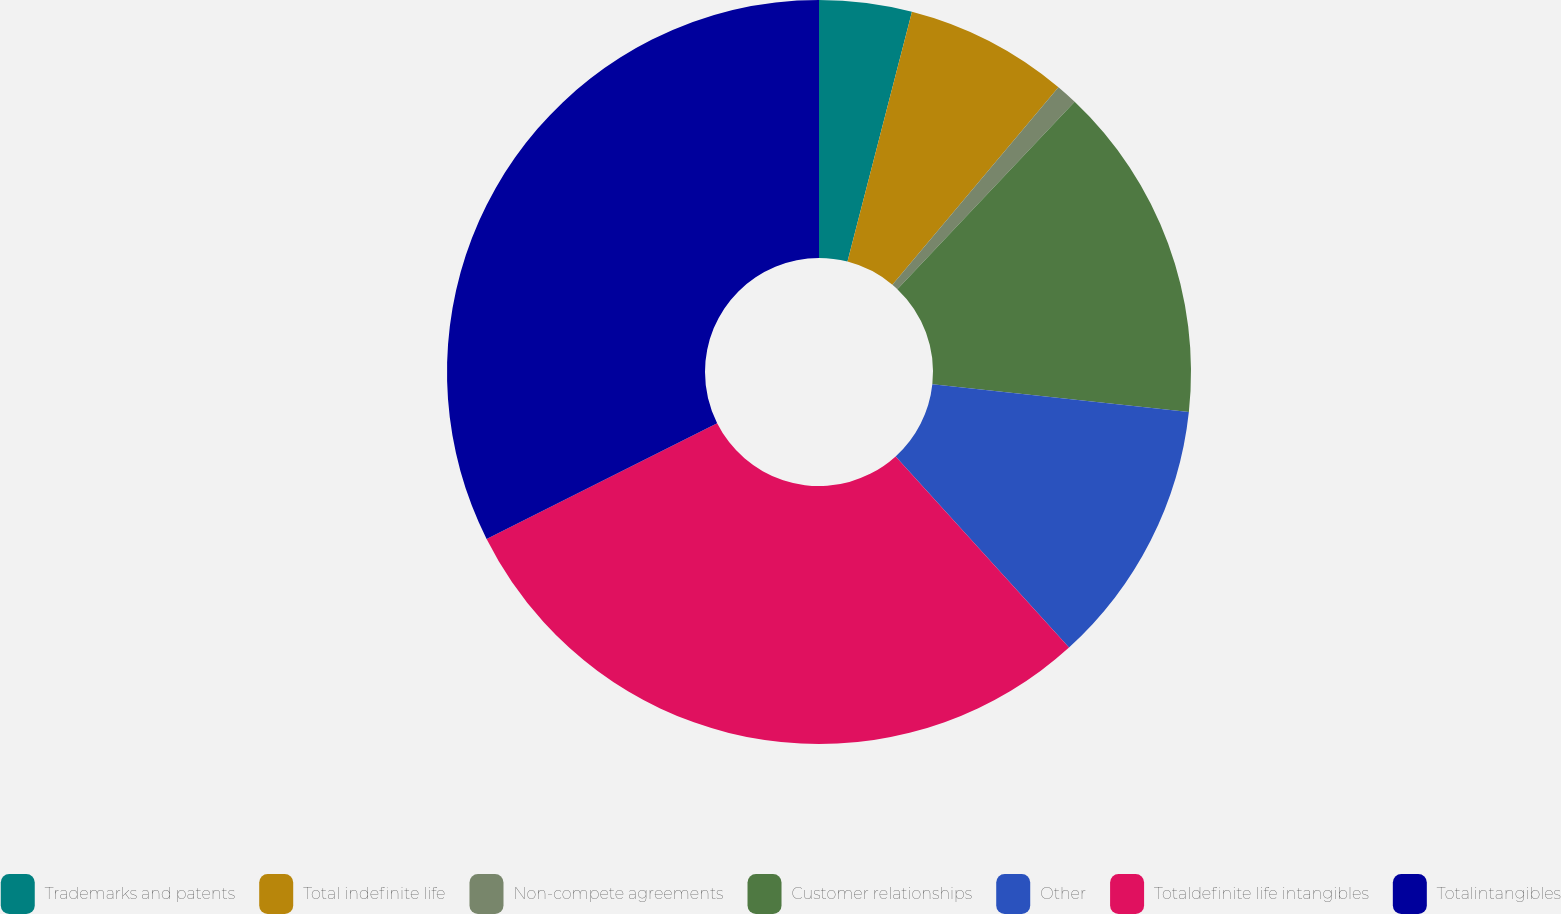<chart> <loc_0><loc_0><loc_500><loc_500><pie_chart><fcel>Trademarks and patents<fcel>Total indefinite life<fcel>Non-compete agreements<fcel>Customer relationships<fcel>Other<fcel>Totaldefinite life intangibles<fcel>Totalintangibles<nl><fcel>4.02%<fcel>7.11%<fcel>0.93%<fcel>14.65%<fcel>11.56%<fcel>29.32%<fcel>32.41%<nl></chart> 